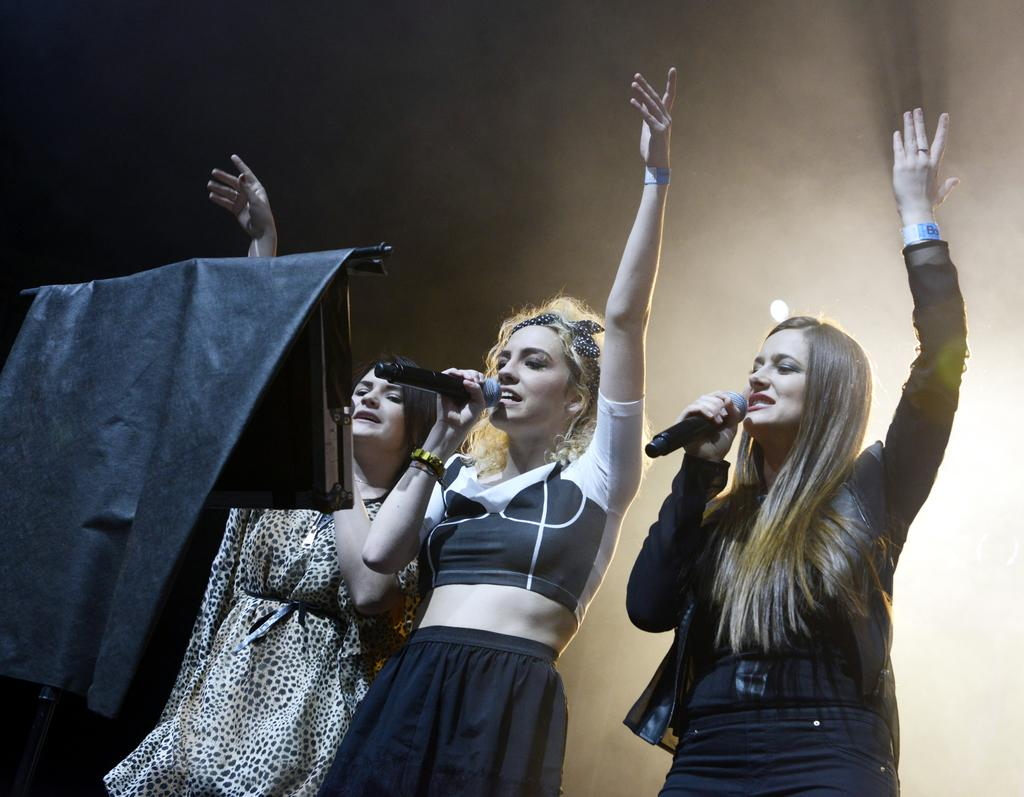How many women are in the image? There are three women in the image. What are the women doing in the image? The women are standing and singing. What objects are the women holding in their hands? The women are holding microphones in their hands. What is in front of the women? There is a stand in front of the women. Can you see a donkey balancing on one leg in the image? No, there is no donkey present in the image, and therefore no such balancing act can be observed. 